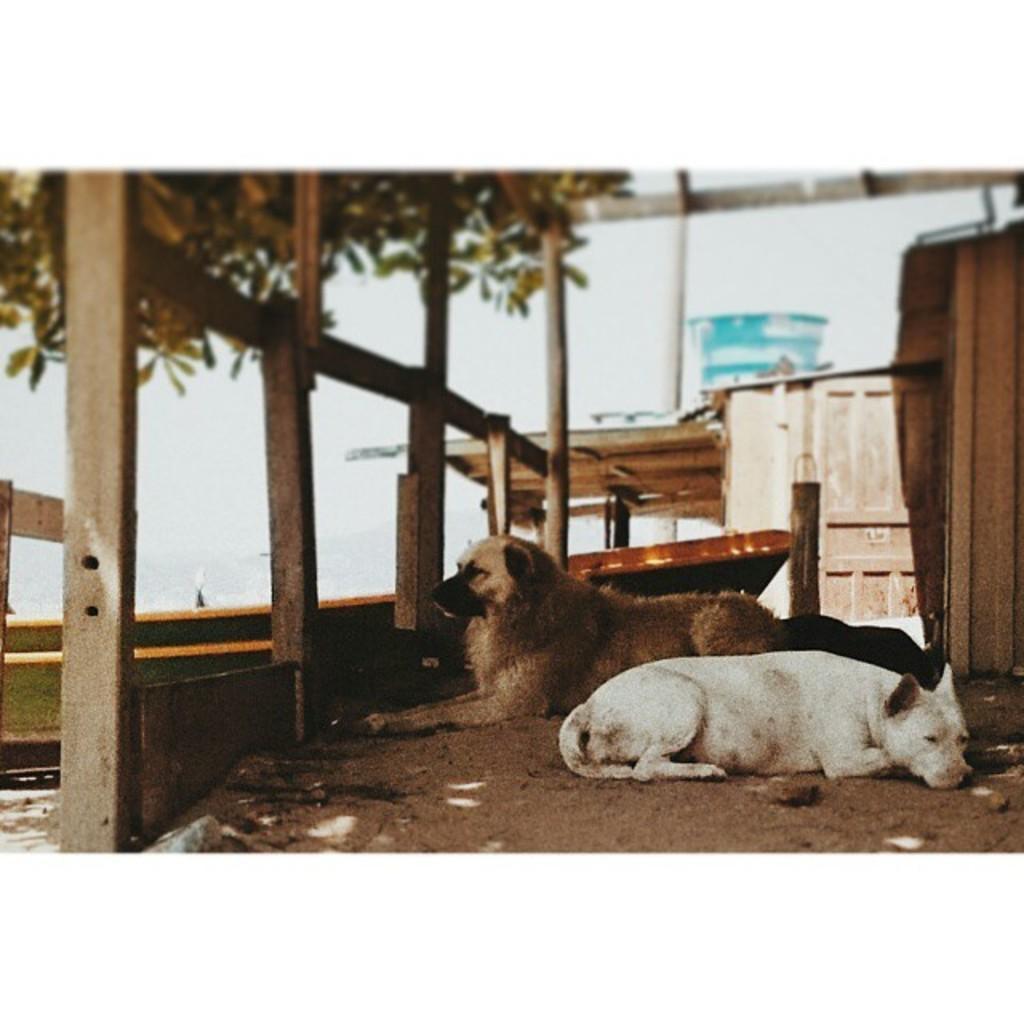How would you summarize this image in a sentence or two? In this picture I can see there are two dogs lying on the soil and there are wooden boxes in the backdrop and there is a building. 